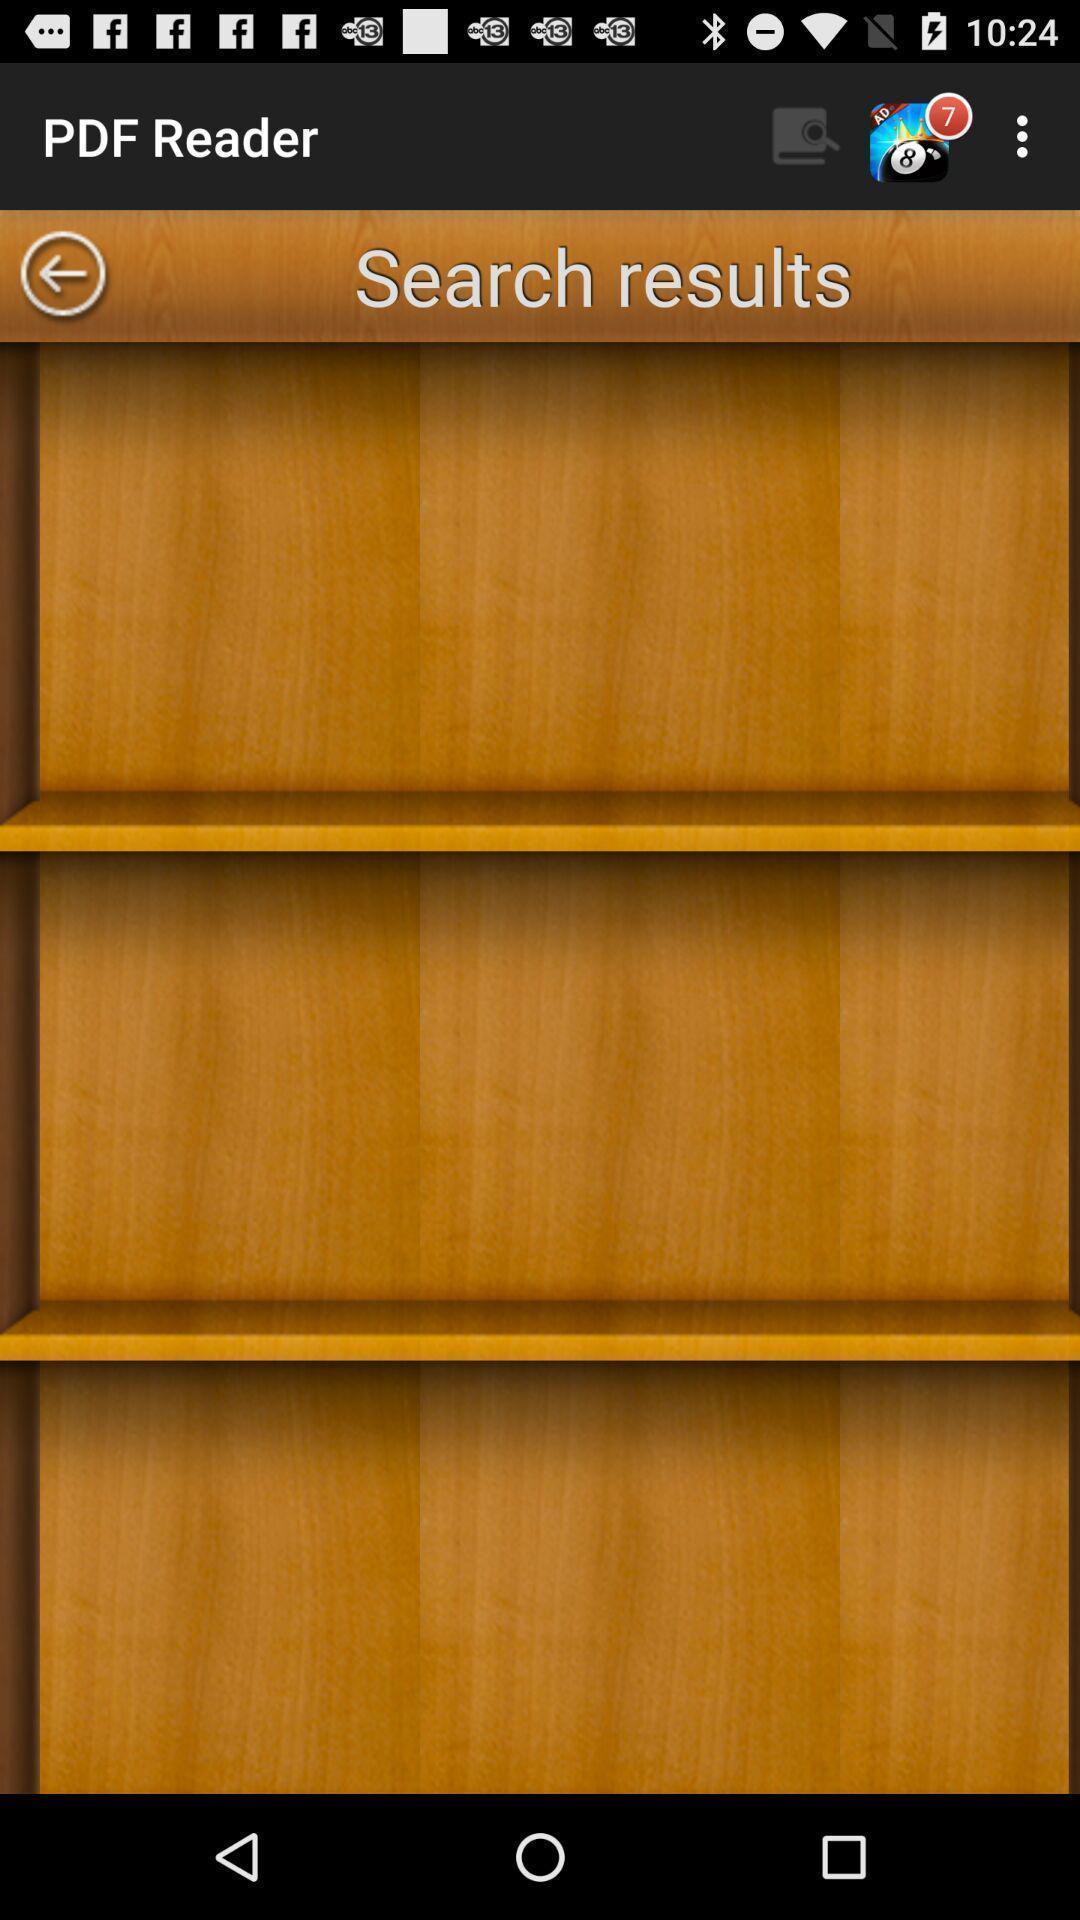Summarize the information in this screenshot. Screen showing search results page. 